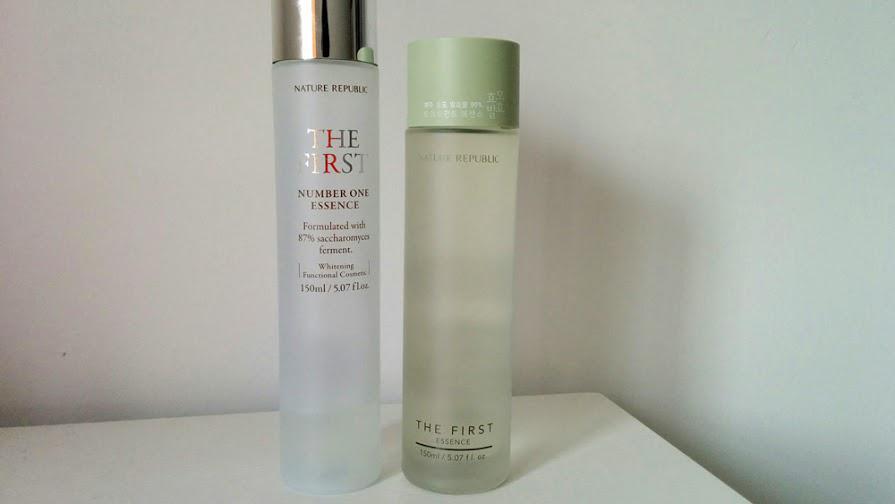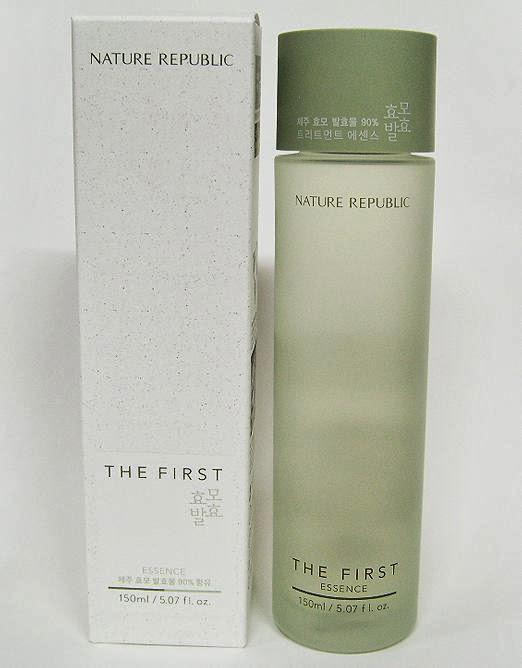The first image is the image on the left, the second image is the image on the right. For the images shown, is this caption "The left image contains one fragrance bottle standing alone, and the right image contains a fragrance bottle to the right of its box." true? Answer yes or no. No. The first image is the image on the left, the second image is the image on the right. Evaluate the accuracy of this statement regarding the images: "At least one bottle in the image on the left has a silver cap.". Is it true? Answer yes or no. Yes. 